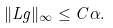Convert formula to latex. <formula><loc_0><loc_0><loc_500><loc_500>\| L g \| _ { \infty } \leq C \alpha .</formula> 